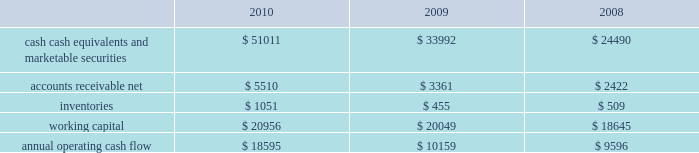Table of contents primarily to certain undistributed foreign earnings for which no u.s .
Taxes are provided because such earnings are intended to be indefinitely reinvested outside the u.s .
The lower effective tax rate in 2010 as compared to 2009 is due primarily to an increase in foreign earnings on which u.s .
Income taxes have not been provided as such earnings are intended to be indefinitely reinvested outside the u.s .
As of september 25 , 2010 , the company had deferred tax assets arising from deductible temporary differences , tax losses , and tax credits of $ 2.4 billion , and deferred tax liabilities of $ 5.0 billion .
Management believes it is more likely than not that forecasted income , including income that may be generated as a result of certain tax planning strategies , together with future reversals of existing taxable temporary differences , will be sufficient to fully recover the deferred tax assets .
The company will continue to evaluate the realizability of deferred tax assets quarterly by assessing the need for and amount of a valuation allowance .
The internal revenue service ( the 201cirs 201d ) has completed its field audit of the company 2019s federal income tax returns for the years 2004 through 2006 and proposed certain adjustments .
The company has contested certain of these adjustments through the irs appeals office .
The irs is currently examining the years 2007 through 2009 .
All irs audit issues for years prior to 2004 have been resolved .
During the third quarter of 2010 , the company reached a tax settlement with the irs for the years 2002 through 2003 .
In addition , the company is subject to audits by state , local , and foreign tax authorities .
Management believes that adequate provision has been made for any adjustments that may result from tax examinations .
However , the outcome of tax audits cannot be predicted with certainty .
If any issues addressed in the company 2019s tax audits are resolved in a manner not consistent with management 2019s expectations , the company could be required to adjust its provision for income taxes in the period such resolution occurs .
Liquidity and capital resources the table presents selected financial information and statistics as of and for the three years ended september 25 , 2010 ( in millions ) : as of september 25 , 2010 , the company had $ 51 billion in cash , cash equivalents and marketable securities , an increase of $ 17 billion from september 26 , 2009 .
The principal component of this net increase was the cash generated by operating activities of $ 18.6 billion , which was partially offset by payments for acquisition of property , plant and equipment of $ 2 billion and payments made in connection with business acquisitions , net of cash acquired , of $ 638 million .
The company 2019s marketable securities investment portfolio is invested primarily in highly rated securities , generally with a minimum rating of single-a or equivalent .
As of september 25 , 2010 and september 26 , 2009 , $ 30.8 billion and $ 17.4 billion , respectively , of the company 2019s cash , cash equivalents and marketable securities were held by foreign subsidiaries and are generally based in u.s .
Dollar-denominated holdings .
The company believes its existing balances of cash , cash equivalents and marketable securities will be sufficient to satisfy its working capital needs , capital asset purchases , outstanding commitments and other liquidity requirements associated with its existing operations over the next 12 months. .

As of september 25 , 2010 , the company had $ 51 billion in cash , cash equivalents and marketable securities . what percentage of the change in 2010 was due to cash generated by operating activities? 
Computations: (18.6 / 51)
Answer: 0.36471. 